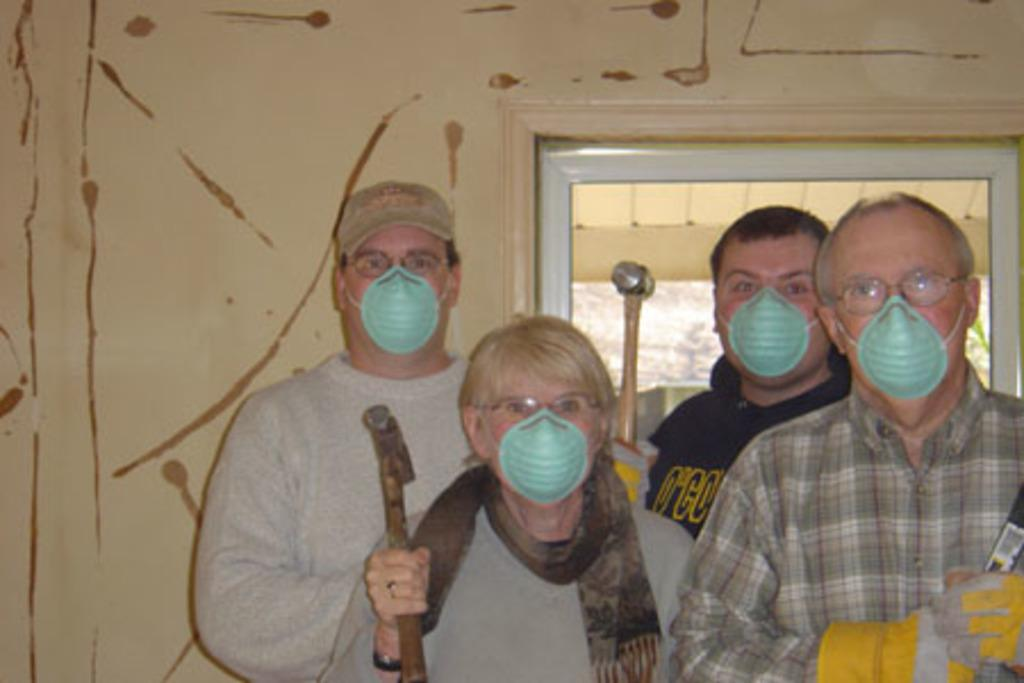How many people are present in the image? There are four people standing in the image. What are the people wearing on their faces? The people are wearing masks. What objects are the people holding in their hands? The people are holding hammers in their hands. What can be seen in the background of the image? There is a wall in the background of the image. Is there any entrance visible in the wall? Yes, there is a door in the wall. What type of vase can be seen on the wall in the image? There is no vase present on the wall in the image. Can you describe the sea visible in the background of the image? There is no sea visible in the background of the image; it features a wall with a door. 